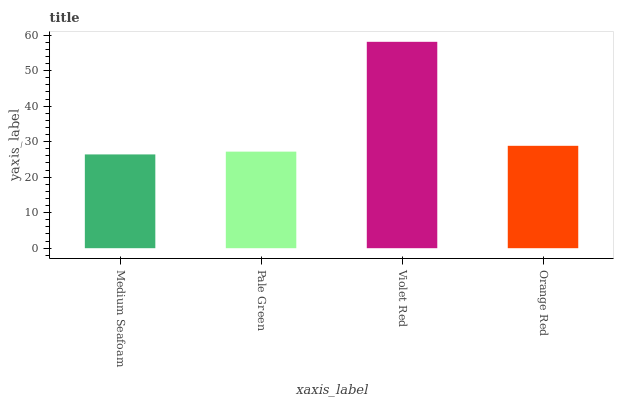Is Medium Seafoam the minimum?
Answer yes or no. Yes. Is Violet Red the maximum?
Answer yes or no. Yes. Is Pale Green the minimum?
Answer yes or no. No. Is Pale Green the maximum?
Answer yes or no. No. Is Pale Green greater than Medium Seafoam?
Answer yes or no. Yes. Is Medium Seafoam less than Pale Green?
Answer yes or no. Yes. Is Medium Seafoam greater than Pale Green?
Answer yes or no. No. Is Pale Green less than Medium Seafoam?
Answer yes or no. No. Is Orange Red the high median?
Answer yes or no. Yes. Is Pale Green the low median?
Answer yes or no. Yes. Is Pale Green the high median?
Answer yes or no. No. Is Orange Red the low median?
Answer yes or no. No. 